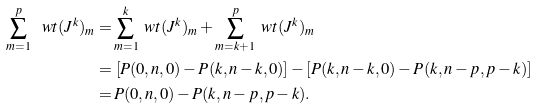<formula> <loc_0><loc_0><loc_500><loc_500>\sum _ { m = 1 } ^ { p } \ w t ( J ^ { k } ) _ { m } = & \sum _ { m = 1 } ^ { k } \ w t ( J ^ { k } ) _ { m } + \sum _ { m = k + 1 } ^ { p } \ w t ( J ^ { k } ) _ { m } \\ = & \, \left [ P ( 0 , n , 0 ) - P ( k , n - k , 0 ) \right ] - \left [ P ( k , n - k , 0 ) - P ( k , n - p , p - k ) \right ] \\ = & \, P ( 0 , n , 0 ) - P ( k , n - p , p - k ) .</formula> 